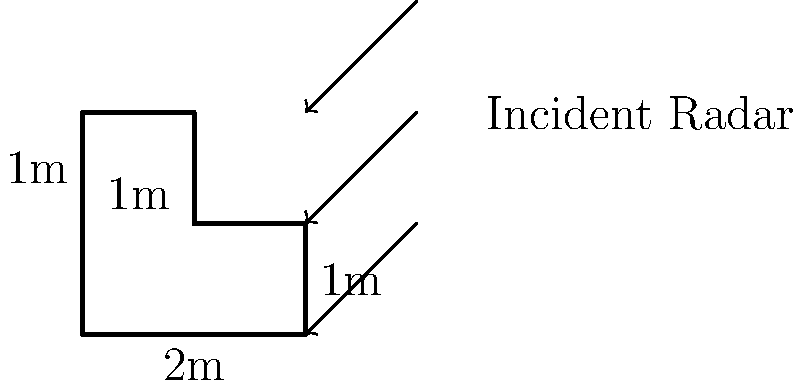A stealth aircraft component has a complex L-shaped cross-section as shown in the diagram. The component is made of a radar-absorbing material with a known radar cross-section (RCS) reduction factor of 0.8. If the RCS of a perfect reflector with the same geometric cross-section is 5 m², calculate the effective RCS of this component. Assume that the incident radar wave is perpendicular to the page and that the component's thickness is negligible compared to its other dimensions. To solve this problem, we'll follow these steps:

1) First, calculate the geometric cross-sectional area of the L-shaped component:
   Area = 2m × 1m + 1m × 1m = 3 m²

2) The given RCS of a perfect reflector with the same geometric cross-section is 5 m². This means that the component, if it were a perfect reflector, would have an RCS of 5 m².

3) However, the component is made of a radar-absorbing material with an RCS reduction factor of 0.8. This means that the actual RCS will be 80% less than that of a perfect reflector.

4) To calculate the effective RCS:
   Effective RCS = Perfect reflector RCS × (1 - Reduction factor)
                 = 5 m² × (1 - 0.8)
                 = 5 m² × 0.2
                 = 1 m²

Therefore, the effective RCS of the component is 1 m².
Answer: 1 m² 